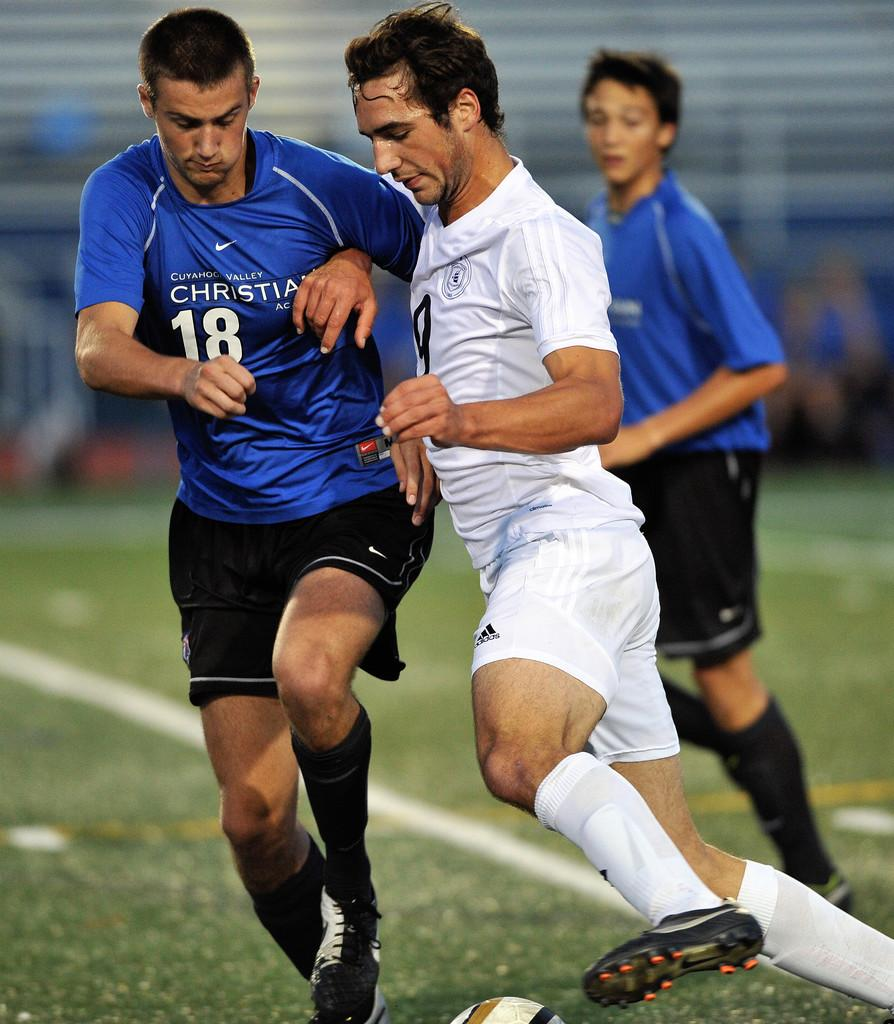<image>
Present a compact description of the photo's key features. the number 18 is on a blue jersey 